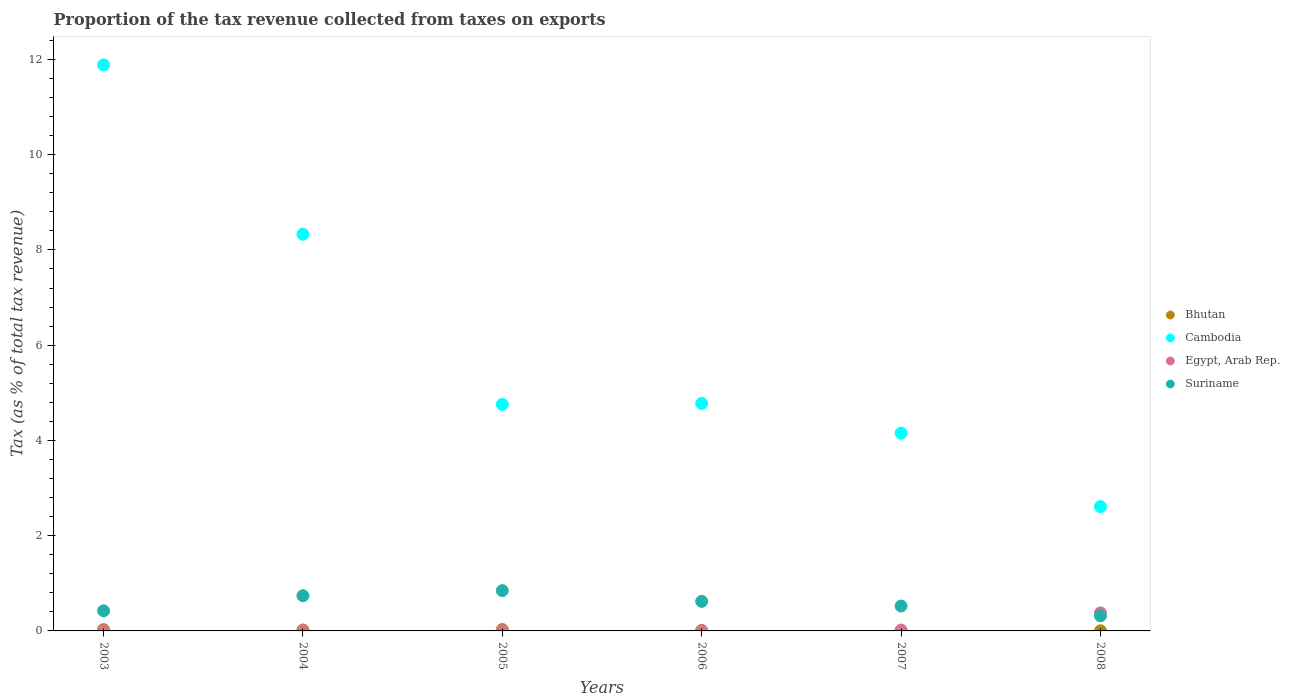What is the proportion of the tax revenue collected in Cambodia in 2004?
Offer a very short reply. 8.33. Across all years, what is the maximum proportion of the tax revenue collected in Bhutan?
Ensure brevity in your answer.  0.03. Across all years, what is the minimum proportion of the tax revenue collected in Bhutan?
Ensure brevity in your answer.  0. What is the total proportion of the tax revenue collected in Suriname in the graph?
Ensure brevity in your answer.  3.47. What is the difference between the proportion of the tax revenue collected in Egypt, Arab Rep. in 2004 and that in 2007?
Make the answer very short. -0.02. What is the difference between the proportion of the tax revenue collected in Bhutan in 2004 and the proportion of the tax revenue collected in Suriname in 2008?
Your response must be concise. -0.3. What is the average proportion of the tax revenue collected in Bhutan per year?
Offer a very short reply. 0.01. In the year 2003, what is the difference between the proportion of the tax revenue collected in Egypt, Arab Rep. and proportion of the tax revenue collected in Suriname?
Your answer should be compact. -0.42. What is the ratio of the proportion of the tax revenue collected in Suriname in 2004 to that in 2007?
Offer a terse response. 1.41. Is the difference between the proportion of the tax revenue collected in Egypt, Arab Rep. in 2004 and 2006 greater than the difference between the proportion of the tax revenue collected in Suriname in 2004 and 2006?
Keep it short and to the point. No. What is the difference between the highest and the second highest proportion of the tax revenue collected in Cambodia?
Offer a terse response. 3.56. What is the difference between the highest and the lowest proportion of the tax revenue collected in Cambodia?
Keep it short and to the point. 9.28. Is it the case that in every year, the sum of the proportion of the tax revenue collected in Egypt, Arab Rep. and proportion of the tax revenue collected in Bhutan  is greater than the sum of proportion of the tax revenue collected in Cambodia and proportion of the tax revenue collected in Suriname?
Offer a very short reply. No. Does the proportion of the tax revenue collected in Suriname monotonically increase over the years?
Your response must be concise. No. Is the proportion of the tax revenue collected in Bhutan strictly less than the proportion of the tax revenue collected in Suriname over the years?
Give a very brief answer. Yes. What is the difference between two consecutive major ticks on the Y-axis?
Offer a terse response. 2. Does the graph contain any zero values?
Provide a short and direct response. No. How are the legend labels stacked?
Provide a succinct answer. Vertical. What is the title of the graph?
Provide a short and direct response. Proportion of the tax revenue collected from taxes on exports. What is the label or title of the X-axis?
Your answer should be very brief. Years. What is the label or title of the Y-axis?
Keep it short and to the point. Tax (as % of total tax revenue). What is the Tax (as % of total tax revenue) of Bhutan in 2003?
Provide a short and direct response. 0.03. What is the Tax (as % of total tax revenue) of Cambodia in 2003?
Offer a terse response. 11.89. What is the Tax (as % of total tax revenue) of Egypt, Arab Rep. in 2003?
Provide a succinct answer. 0. What is the Tax (as % of total tax revenue) of Suriname in 2003?
Ensure brevity in your answer.  0.42. What is the Tax (as % of total tax revenue) of Bhutan in 2004?
Your answer should be very brief. 0.02. What is the Tax (as % of total tax revenue) in Cambodia in 2004?
Your answer should be very brief. 8.33. What is the Tax (as % of total tax revenue) of Egypt, Arab Rep. in 2004?
Your answer should be very brief. 0. What is the Tax (as % of total tax revenue) in Suriname in 2004?
Your answer should be very brief. 0.74. What is the Tax (as % of total tax revenue) of Bhutan in 2005?
Ensure brevity in your answer.  0.03. What is the Tax (as % of total tax revenue) of Cambodia in 2005?
Offer a terse response. 4.76. What is the Tax (as % of total tax revenue) in Egypt, Arab Rep. in 2005?
Give a very brief answer. 0. What is the Tax (as % of total tax revenue) in Suriname in 2005?
Keep it short and to the point. 0.85. What is the Tax (as % of total tax revenue) of Bhutan in 2006?
Your response must be concise. 0.01. What is the Tax (as % of total tax revenue) in Cambodia in 2006?
Your answer should be compact. 4.78. What is the Tax (as % of total tax revenue) in Egypt, Arab Rep. in 2006?
Provide a succinct answer. 0. What is the Tax (as % of total tax revenue) of Suriname in 2006?
Your answer should be very brief. 0.62. What is the Tax (as % of total tax revenue) in Bhutan in 2007?
Your response must be concise. 0. What is the Tax (as % of total tax revenue) of Cambodia in 2007?
Your response must be concise. 4.15. What is the Tax (as % of total tax revenue) in Egypt, Arab Rep. in 2007?
Your response must be concise. 0.02. What is the Tax (as % of total tax revenue) in Suriname in 2007?
Offer a very short reply. 0.52. What is the Tax (as % of total tax revenue) of Bhutan in 2008?
Provide a short and direct response. 0. What is the Tax (as % of total tax revenue) of Cambodia in 2008?
Provide a short and direct response. 2.61. What is the Tax (as % of total tax revenue) in Egypt, Arab Rep. in 2008?
Offer a terse response. 0.38. What is the Tax (as % of total tax revenue) of Suriname in 2008?
Offer a terse response. 0.32. Across all years, what is the maximum Tax (as % of total tax revenue) in Bhutan?
Provide a short and direct response. 0.03. Across all years, what is the maximum Tax (as % of total tax revenue) in Cambodia?
Provide a short and direct response. 11.89. Across all years, what is the maximum Tax (as % of total tax revenue) of Egypt, Arab Rep.?
Provide a short and direct response. 0.38. Across all years, what is the maximum Tax (as % of total tax revenue) in Suriname?
Give a very brief answer. 0.85. Across all years, what is the minimum Tax (as % of total tax revenue) of Bhutan?
Offer a terse response. 0. Across all years, what is the minimum Tax (as % of total tax revenue) of Cambodia?
Your response must be concise. 2.61. Across all years, what is the minimum Tax (as % of total tax revenue) in Egypt, Arab Rep.?
Make the answer very short. 0. Across all years, what is the minimum Tax (as % of total tax revenue) in Suriname?
Offer a very short reply. 0.32. What is the total Tax (as % of total tax revenue) of Bhutan in the graph?
Provide a succinct answer. 0.09. What is the total Tax (as % of total tax revenue) of Cambodia in the graph?
Provide a short and direct response. 36.51. What is the total Tax (as % of total tax revenue) of Egypt, Arab Rep. in the graph?
Offer a terse response. 0.4. What is the total Tax (as % of total tax revenue) of Suriname in the graph?
Make the answer very short. 3.47. What is the difference between the Tax (as % of total tax revenue) of Bhutan in 2003 and that in 2004?
Your response must be concise. 0.01. What is the difference between the Tax (as % of total tax revenue) in Cambodia in 2003 and that in 2004?
Offer a terse response. 3.56. What is the difference between the Tax (as % of total tax revenue) in Egypt, Arab Rep. in 2003 and that in 2004?
Provide a succinct answer. -0. What is the difference between the Tax (as % of total tax revenue) of Suriname in 2003 and that in 2004?
Your response must be concise. -0.32. What is the difference between the Tax (as % of total tax revenue) of Bhutan in 2003 and that in 2005?
Give a very brief answer. -0. What is the difference between the Tax (as % of total tax revenue) in Cambodia in 2003 and that in 2005?
Your answer should be compact. 7.13. What is the difference between the Tax (as % of total tax revenue) of Egypt, Arab Rep. in 2003 and that in 2005?
Offer a terse response. 0. What is the difference between the Tax (as % of total tax revenue) of Suriname in 2003 and that in 2005?
Provide a succinct answer. -0.42. What is the difference between the Tax (as % of total tax revenue) in Bhutan in 2003 and that in 2006?
Keep it short and to the point. 0.02. What is the difference between the Tax (as % of total tax revenue) in Cambodia in 2003 and that in 2006?
Your answer should be very brief. 7.11. What is the difference between the Tax (as % of total tax revenue) of Suriname in 2003 and that in 2006?
Give a very brief answer. -0.2. What is the difference between the Tax (as % of total tax revenue) in Bhutan in 2003 and that in 2007?
Offer a terse response. 0.03. What is the difference between the Tax (as % of total tax revenue) in Cambodia in 2003 and that in 2007?
Offer a terse response. 7.73. What is the difference between the Tax (as % of total tax revenue) in Egypt, Arab Rep. in 2003 and that in 2007?
Provide a short and direct response. -0.02. What is the difference between the Tax (as % of total tax revenue) of Suriname in 2003 and that in 2007?
Provide a succinct answer. -0.1. What is the difference between the Tax (as % of total tax revenue) of Bhutan in 2003 and that in 2008?
Keep it short and to the point. 0.03. What is the difference between the Tax (as % of total tax revenue) of Cambodia in 2003 and that in 2008?
Provide a short and direct response. 9.28. What is the difference between the Tax (as % of total tax revenue) of Egypt, Arab Rep. in 2003 and that in 2008?
Your answer should be very brief. -0.38. What is the difference between the Tax (as % of total tax revenue) of Suriname in 2003 and that in 2008?
Ensure brevity in your answer.  0.1. What is the difference between the Tax (as % of total tax revenue) of Bhutan in 2004 and that in 2005?
Ensure brevity in your answer.  -0.01. What is the difference between the Tax (as % of total tax revenue) of Cambodia in 2004 and that in 2005?
Provide a short and direct response. 3.57. What is the difference between the Tax (as % of total tax revenue) of Egypt, Arab Rep. in 2004 and that in 2005?
Offer a very short reply. 0. What is the difference between the Tax (as % of total tax revenue) of Suriname in 2004 and that in 2005?
Your response must be concise. -0.11. What is the difference between the Tax (as % of total tax revenue) of Bhutan in 2004 and that in 2006?
Offer a very short reply. 0.01. What is the difference between the Tax (as % of total tax revenue) in Cambodia in 2004 and that in 2006?
Your response must be concise. 3.55. What is the difference between the Tax (as % of total tax revenue) in Egypt, Arab Rep. in 2004 and that in 2006?
Ensure brevity in your answer.  0. What is the difference between the Tax (as % of total tax revenue) of Suriname in 2004 and that in 2006?
Provide a succinct answer. 0.12. What is the difference between the Tax (as % of total tax revenue) of Bhutan in 2004 and that in 2007?
Keep it short and to the point. 0.02. What is the difference between the Tax (as % of total tax revenue) in Cambodia in 2004 and that in 2007?
Your answer should be very brief. 4.18. What is the difference between the Tax (as % of total tax revenue) of Egypt, Arab Rep. in 2004 and that in 2007?
Your answer should be compact. -0.02. What is the difference between the Tax (as % of total tax revenue) of Suriname in 2004 and that in 2007?
Ensure brevity in your answer.  0.22. What is the difference between the Tax (as % of total tax revenue) in Bhutan in 2004 and that in 2008?
Give a very brief answer. 0.02. What is the difference between the Tax (as % of total tax revenue) in Cambodia in 2004 and that in 2008?
Give a very brief answer. 5.72. What is the difference between the Tax (as % of total tax revenue) of Egypt, Arab Rep. in 2004 and that in 2008?
Your response must be concise. -0.38. What is the difference between the Tax (as % of total tax revenue) in Suriname in 2004 and that in 2008?
Your answer should be compact. 0.42. What is the difference between the Tax (as % of total tax revenue) in Bhutan in 2005 and that in 2006?
Make the answer very short. 0.02. What is the difference between the Tax (as % of total tax revenue) of Cambodia in 2005 and that in 2006?
Offer a very short reply. -0.02. What is the difference between the Tax (as % of total tax revenue) in Egypt, Arab Rep. in 2005 and that in 2006?
Offer a terse response. -0. What is the difference between the Tax (as % of total tax revenue) of Suriname in 2005 and that in 2006?
Offer a very short reply. 0.23. What is the difference between the Tax (as % of total tax revenue) of Bhutan in 2005 and that in 2007?
Provide a succinct answer. 0.03. What is the difference between the Tax (as % of total tax revenue) in Cambodia in 2005 and that in 2007?
Ensure brevity in your answer.  0.6. What is the difference between the Tax (as % of total tax revenue) of Egypt, Arab Rep. in 2005 and that in 2007?
Provide a succinct answer. -0.02. What is the difference between the Tax (as % of total tax revenue) of Suriname in 2005 and that in 2007?
Provide a short and direct response. 0.32. What is the difference between the Tax (as % of total tax revenue) in Bhutan in 2005 and that in 2008?
Make the answer very short. 0.03. What is the difference between the Tax (as % of total tax revenue) of Cambodia in 2005 and that in 2008?
Ensure brevity in your answer.  2.15. What is the difference between the Tax (as % of total tax revenue) of Egypt, Arab Rep. in 2005 and that in 2008?
Give a very brief answer. -0.38. What is the difference between the Tax (as % of total tax revenue) of Suriname in 2005 and that in 2008?
Your answer should be compact. 0.53. What is the difference between the Tax (as % of total tax revenue) in Bhutan in 2006 and that in 2007?
Make the answer very short. 0.01. What is the difference between the Tax (as % of total tax revenue) of Cambodia in 2006 and that in 2007?
Your answer should be compact. 0.62. What is the difference between the Tax (as % of total tax revenue) in Egypt, Arab Rep. in 2006 and that in 2007?
Offer a very short reply. -0.02. What is the difference between the Tax (as % of total tax revenue) in Suriname in 2006 and that in 2007?
Offer a terse response. 0.1. What is the difference between the Tax (as % of total tax revenue) of Bhutan in 2006 and that in 2008?
Your response must be concise. 0.01. What is the difference between the Tax (as % of total tax revenue) of Cambodia in 2006 and that in 2008?
Keep it short and to the point. 2.17. What is the difference between the Tax (as % of total tax revenue) of Egypt, Arab Rep. in 2006 and that in 2008?
Keep it short and to the point. -0.38. What is the difference between the Tax (as % of total tax revenue) in Suriname in 2006 and that in 2008?
Give a very brief answer. 0.3. What is the difference between the Tax (as % of total tax revenue) of Bhutan in 2007 and that in 2008?
Make the answer very short. -0. What is the difference between the Tax (as % of total tax revenue) in Cambodia in 2007 and that in 2008?
Offer a very short reply. 1.54. What is the difference between the Tax (as % of total tax revenue) of Egypt, Arab Rep. in 2007 and that in 2008?
Provide a succinct answer. -0.36. What is the difference between the Tax (as % of total tax revenue) in Suriname in 2007 and that in 2008?
Offer a very short reply. 0.2. What is the difference between the Tax (as % of total tax revenue) of Bhutan in 2003 and the Tax (as % of total tax revenue) of Cambodia in 2004?
Ensure brevity in your answer.  -8.3. What is the difference between the Tax (as % of total tax revenue) of Bhutan in 2003 and the Tax (as % of total tax revenue) of Egypt, Arab Rep. in 2004?
Offer a very short reply. 0.03. What is the difference between the Tax (as % of total tax revenue) of Bhutan in 2003 and the Tax (as % of total tax revenue) of Suriname in 2004?
Provide a succinct answer. -0.71. What is the difference between the Tax (as % of total tax revenue) in Cambodia in 2003 and the Tax (as % of total tax revenue) in Egypt, Arab Rep. in 2004?
Provide a succinct answer. 11.88. What is the difference between the Tax (as % of total tax revenue) in Cambodia in 2003 and the Tax (as % of total tax revenue) in Suriname in 2004?
Your answer should be compact. 11.15. What is the difference between the Tax (as % of total tax revenue) of Egypt, Arab Rep. in 2003 and the Tax (as % of total tax revenue) of Suriname in 2004?
Provide a succinct answer. -0.74. What is the difference between the Tax (as % of total tax revenue) of Bhutan in 2003 and the Tax (as % of total tax revenue) of Cambodia in 2005?
Provide a succinct answer. -4.73. What is the difference between the Tax (as % of total tax revenue) of Bhutan in 2003 and the Tax (as % of total tax revenue) of Egypt, Arab Rep. in 2005?
Your response must be concise. 0.03. What is the difference between the Tax (as % of total tax revenue) in Bhutan in 2003 and the Tax (as % of total tax revenue) in Suriname in 2005?
Your answer should be compact. -0.82. What is the difference between the Tax (as % of total tax revenue) of Cambodia in 2003 and the Tax (as % of total tax revenue) of Egypt, Arab Rep. in 2005?
Give a very brief answer. 11.88. What is the difference between the Tax (as % of total tax revenue) of Cambodia in 2003 and the Tax (as % of total tax revenue) of Suriname in 2005?
Ensure brevity in your answer.  11.04. What is the difference between the Tax (as % of total tax revenue) in Egypt, Arab Rep. in 2003 and the Tax (as % of total tax revenue) in Suriname in 2005?
Your response must be concise. -0.84. What is the difference between the Tax (as % of total tax revenue) of Bhutan in 2003 and the Tax (as % of total tax revenue) of Cambodia in 2006?
Offer a very short reply. -4.75. What is the difference between the Tax (as % of total tax revenue) of Bhutan in 2003 and the Tax (as % of total tax revenue) of Egypt, Arab Rep. in 2006?
Offer a terse response. 0.03. What is the difference between the Tax (as % of total tax revenue) in Bhutan in 2003 and the Tax (as % of total tax revenue) in Suriname in 2006?
Your answer should be compact. -0.59. What is the difference between the Tax (as % of total tax revenue) of Cambodia in 2003 and the Tax (as % of total tax revenue) of Egypt, Arab Rep. in 2006?
Make the answer very short. 11.88. What is the difference between the Tax (as % of total tax revenue) in Cambodia in 2003 and the Tax (as % of total tax revenue) in Suriname in 2006?
Provide a succinct answer. 11.27. What is the difference between the Tax (as % of total tax revenue) of Egypt, Arab Rep. in 2003 and the Tax (as % of total tax revenue) of Suriname in 2006?
Offer a terse response. -0.62. What is the difference between the Tax (as % of total tax revenue) of Bhutan in 2003 and the Tax (as % of total tax revenue) of Cambodia in 2007?
Keep it short and to the point. -4.12. What is the difference between the Tax (as % of total tax revenue) in Bhutan in 2003 and the Tax (as % of total tax revenue) in Egypt, Arab Rep. in 2007?
Provide a short and direct response. 0.01. What is the difference between the Tax (as % of total tax revenue) in Bhutan in 2003 and the Tax (as % of total tax revenue) in Suriname in 2007?
Give a very brief answer. -0.49. What is the difference between the Tax (as % of total tax revenue) of Cambodia in 2003 and the Tax (as % of total tax revenue) of Egypt, Arab Rep. in 2007?
Make the answer very short. 11.87. What is the difference between the Tax (as % of total tax revenue) of Cambodia in 2003 and the Tax (as % of total tax revenue) of Suriname in 2007?
Your answer should be very brief. 11.36. What is the difference between the Tax (as % of total tax revenue) in Egypt, Arab Rep. in 2003 and the Tax (as % of total tax revenue) in Suriname in 2007?
Give a very brief answer. -0.52. What is the difference between the Tax (as % of total tax revenue) of Bhutan in 2003 and the Tax (as % of total tax revenue) of Cambodia in 2008?
Your response must be concise. -2.58. What is the difference between the Tax (as % of total tax revenue) of Bhutan in 2003 and the Tax (as % of total tax revenue) of Egypt, Arab Rep. in 2008?
Your answer should be very brief. -0.35. What is the difference between the Tax (as % of total tax revenue) in Bhutan in 2003 and the Tax (as % of total tax revenue) in Suriname in 2008?
Give a very brief answer. -0.29. What is the difference between the Tax (as % of total tax revenue) in Cambodia in 2003 and the Tax (as % of total tax revenue) in Egypt, Arab Rep. in 2008?
Keep it short and to the point. 11.51. What is the difference between the Tax (as % of total tax revenue) of Cambodia in 2003 and the Tax (as % of total tax revenue) of Suriname in 2008?
Offer a very short reply. 11.57. What is the difference between the Tax (as % of total tax revenue) of Egypt, Arab Rep. in 2003 and the Tax (as % of total tax revenue) of Suriname in 2008?
Keep it short and to the point. -0.32. What is the difference between the Tax (as % of total tax revenue) of Bhutan in 2004 and the Tax (as % of total tax revenue) of Cambodia in 2005?
Your answer should be very brief. -4.74. What is the difference between the Tax (as % of total tax revenue) in Bhutan in 2004 and the Tax (as % of total tax revenue) in Egypt, Arab Rep. in 2005?
Provide a succinct answer. 0.02. What is the difference between the Tax (as % of total tax revenue) of Bhutan in 2004 and the Tax (as % of total tax revenue) of Suriname in 2005?
Give a very brief answer. -0.83. What is the difference between the Tax (as % of total tax revenue) in Cambodia in 2004 and the Tax (as % of total tax revenue) in Egypt, Arab Rep. in 2005?
Keep it short and to the point. 8.33. What is the difference between the Tax (as % of total tax revenue) of Cambodia in 2004 and the Tax (as % of total tax revenue) of Suriname in 2005?
Provide a succinct answer. 7.48. What is the difference between the Tax (as % of total tax revenue) in Egypt, Arab Rep. in 2004 and the Tax (as % of total tax revenue) in Suriname in 2005?
Give a very brief answer. -0.84. What is the difference between the Tax (as % of total tax revenue) of Bhutan in 2004 and the Tax (as % of total tax revenue) of Cambodia in 2006?
Make the answer very short. -4.76. What is the difference between the Tax (as % of total tax revenue) in Bhutan in 2004 and the Tax (as % of total tax revenue) in Egypt, Arab Rep. in 2006?
Your answer should be very brief. 0.02. What is the difference between the Tax (as % of total tax revenue) in Bhutan in 2004 and the Tax (as % of total tax revenue) in Suriname in 2006?
Keep it short and to the point. -0.6. What is the difference between the Tax (as % of total tax revenue) of Cambodia in 2004 and the Tax (as % of total tax revenue) of Egypt, Arab Rep. in 2006?
Ensure brevity in your answer.  8.33. What is the difference between the Tax (as % of total tax revenue) in Cambodia in 2004 and the Tax (as % of total tax revenue) in Suriname in 2006?
Your response must be concise. 7.71. What is the difference between the Tax (as % of total tax revenue) of Egypt, Arab Rep. in 2004 and the Tax (as % of total tax revenue) of Suriname in 2006?
Your answer should be very brief. -0.62. What is the difference between the Tax (as % of total tax revenue) in Bhutan in 2004 and the Tax (as % of total tax revenue) in Cambodia in 2007?
Offer a very short reply. -4.13. What is the difference between the Tax (as % of total tax revenue) in Bhutan in 2004 and the Tax (as % of total tax revenue) in Egypt, Arab Rep. in 2007?
Make the answer very short. 0. What is the difference between the Tax (as % of total tax revenue) of Bhutan in 2004 and the Tax (as % of total tax revenue) of Suriname in 2007?
Your answer should be compact. -0.5. What is the difference between the Tax (as % of total tax revenue) of Cambodia in 2004 and the Tax (as % of total tax revenue) of Egypt, Arab Rep. in 2007?
Provide a short and direct response. 8.31. What is the difference between the Tax (as % of total tax revenue) of Cambodia in 2004 and the Tax (as % of total tax revenue) of Suriname in 2007?
Provide a succinct answer. 7.81. What is the difference between the Tax (as % of total tax revenue) in Egypt, Arab Rep. in 2004 and the Tax (as % of total tax revenue) in Suriname in 2007?
Keep it short and to the point. -0.52. What is the difference between the Tax (as % of total tax revenue) in Bhutan in 2004 and the Tax (as % of total tax revenue) in Cambodia in 2008?
Your answer should be compact. -2.59. What is the difference between the Tax (as % of total tax revenue) in Bhutan in 2004 and the Tax (as % of total tax revenue) in Egypt, Arab Rep. in 2008?
Offer a terse response. -0.36. What is the difference between the Tax (as % of total tax revenue) in Bhutan in 2004 and the Tax (as % of total tax revenue) in Suriname in 2008?
Your answer should be very brief. -0.3. What is the difference between the Tax (as % of total tax revenue) of Cambodia in 2004 and the Tax (as % of total tax revenue) of Egypt, Arab Rep. in 2008?
Ensure brevity in your answer.  7.95. What is the difference between the Tax (as % of total tax revenue) of Cambodia in 2004 and the Tax (as % of total tax revenue) of Suriname in 2008?
Offer a very short reply. 8.01. What is the difference between the Tax (as % of total tax revenue) in Egypt, Arab Rep. in 2004 and the Tax (as % of total tax revenue) in Suriname in 2008?
Your response must be concise. -0.32. What is the difference between the Tax (as % of total tax revenue) of Bhutan in 2005 and the Tax (as % of total tax revenue) of Cambodia in 2006?
Provide a short and direct response. -4.75. What is the difference between the Tax (as % of total tax revenue) of Bhutan in 2005 and the Tax (as % of total tax revenue) of Egypt, Arab Rep. in 2006?
Offer a very short reply. 0.03. What is the difference between the Tax (as % of total tax revenue) in Bhutan in 2005 and the Tax (as % of total tax revenue) in Suriname in 2006?
Your answer should be compact. -0.59. What is the difference between the Tax (as % of total tax revenue) in Cambodia in 2005 and the Tax (as % of total tax revenue) in Egypt, Arab Rep. in 2006?
Make the answer very short. 4.75. What is the difference between the Tax (as % of total tax revenue) of Cambodia in 2005 and the Tax (as % of total tax revenue) of Suriname in 2006?
Ensure brevity in your answer.  4.14. What is the difference between the Tax (as % of total tax revenue) in Egypt, Arab Rep. in 2005 and the Tax (as % of total tax revenue) in Suriname in 2006?
Ensure brevity in your answer.  -0.62. What is the difference between the Tax (as % of total tax revenue) of Bhutan in 2005 and the Tax (as % of total tax revenue) of Cambodia in 2007?
Keep it short and to the point. -4.12. What is the difference between the Tax (as % of total tax revenue) in Bhutan in 2005 and the Tax (as % of total tax revenue) in Suriname in 2007?
Your response must be concise. -0.49. What is the difference between the Tax (as % of total tax revenue) in Cambodia in 2005 and the Tax (as % of total tax revenue) in Egypt, Arab Rep. in 2007?
Offer a very short reply. 4.74. What is the difference between the Tax (as % of total tax revenue) in Cambodia in 2005 and the Tax (as % of total tax revenue) in Suriname in 2007?
Keep it short and to the point. 4.23. What is the difference between the Tax (as % of total tax revenue) of Egypt, Arab Rep. in 2005 and the Tax (as % of total tax revenue) of Suriname in 2007?
Offer a very short reply. -0.52. What is the difference between the Tax (as % of total tax revenue) in Bhutan in 2005 and the Tax (as % of total tax revenue) in Cambodia in 2008?
Keep it short and to the point. -2.58. What is the difference between the Tax (as % of total tax revenue) in Bhutan in 2005 and the Tax (as % of total tax revenue) in Egypt, Arab Rep. in 2008?
Provide a succinct answer. -0.35. What is the difference between the Tax (as % of total tax revenue) in Bhutan in 2005 and the Tax (as % of total tax revenue) in Suriname in 2008?
Provide a succinct answer. -0.29. What is the difference between the Tax (as % of total tax revenue) in Cambodia in 2005 and the Tax (as % of total tax revenue) in Egypt, Arab Rep. in 2008?
Offer a terse response. 4.38. What is the difference between the Tax (as % of total tax revenue) in Cambodia in 2005 and the Tax (as % of total tax revenue) in Suriname in 2008?
Ensure brevity in your answer.  4.44. What is the difference between the Tax (as % of total tax revenue) of Egypt, Arab Rep. in 2005 and the Tax (as % of total tax revenue) of Suriname in 2008?
Your answer should be very brief. -0.32. What is the difference between the Tax (as % of total tax revenue) of Bhutan in 2006 and the Tax (as % of total tax revenue) of Cambodia in 2007?
Offer a terse response. -4.14. What is the difference between the Tax (as % of total tax revenue) of Bhutan in 2006 and the Tax (as % of total tax revenue) of Egypt, Arab Rep. in 2007?
Give a very brief answer. -0.01. What is the difference between the Tax (as % of total tax revenue) of Bhutan in 2006 and the Tax (as % of total tax revenue) of Suriname in 2007?
Ensure brevity in your answer.  -0.51. What is the difference between the Tax (as % of total tax revenue) in Cambodia in 2006 and the Tax (as % of total tax revenue) in Egypt, Arab Rep. in 2007?
Your answer should be compact. 4.76. What is the difference between the Tax (as % of total tax revenue) of Cambodia in 2006 and the Tax (as % of total tax revenue) of Suriname in 2007?
Ensure brevity in your answer.  4.25. What is the difference between the Tax (as % of total tax revenue) in Egypt, Arab Rep. in 2006 and the Tax (as % of total tax revenue) in Suriname in 2007?
Make the answer very short. -0.52. What is the difference between the Tax (as % of total tax revenue) in Bhutan in 2006 and the Tax (as % of total tax revenue) in Cambodia in 2008?
Your answer should be very brief. -2.6. What is the difference between the Tax (as % of total tax revenue) in Bhutan in 2006 and the Tax (as % of total tax revenue) in Egypt, Arab Rep. in 2008?
Offer a very short reply. -0.37. What is the difference between the Tax (as % of total tax revenue) in Bhutan in 2006 and the Tax (as % of total tax revenue) in Suriname in 2008?
Offer a very short reply. -0.31. What is the difference between the Tax (as % of total tax revenue) in Cambodia in 2006 and the Tax (as % of total tax revenue) in Egypt, Arab Rep. in 2008?
Your answer should be very brief. 4.4. What is the difference between the Tax (as % of total tax revenue) in Cambodia in 2006 and the Tax (as % of total tax revenue) in Suriname in 2008?
Make the answer very short. 4.46. What is the difference between the Tax (as % of total tax revenue) in Egypt, Arab Rep. in 2006 and the Tax (as % of total tax revenue) in Suriname in 2008?
Your response must be concise. -0.32. What is the difference between the Tax (as % of total tax revenue) in Bhutan in 2007 and the Tax (as % of total tax revenue) in Cambodia in 2008?
Provide a short and direct response. -2.61. What is the difference between the Tax (as % of total tax revenue) of Bhutan in 2007 and the Tax (as % of total tax revenue) of Egypt, Arab Rep. in 2008?
Provide a succinct answer. -0.38. What is the difference between the Tax (as % of total tax revenue) of Bhutan in 2007 and the Tax (as % of total tax revenue) of Suriname in 2008?
Make the answer very short. -0.32. What is the difference between the Tax (as % of total tax revenue) in Cambodia in 2007 and the Tax (as % of total tax revenue) in Egypt, Arab Rep. in 2008?
Provide a short and direct response. 3.77. What is the difference between the Tax (as % of total tax revenue) of Cambodia in 2007 and the Tax (as % of total tax revenue) of Suriname in 2008?
Offer a very short reply. 3.83. What is the difference between the Tax (as % of total tax revenue) in Egypt, Arab Rep. in 2007 and the Tax (as % of total tax revenue) in Suriname in 2008?
Ensure brevity in your answer.  -0.3. What is the average Tax (as % of total tax revenue) in Bhutan per year?
Make the answer very short. 0.01. What is the average Tax (as % of total tax revenue) in Cambodia per year?
Keep it short and to the point. 6.09. What is the average Tax (as % of total tax revenue) in Egypt, Arab Rep. per year?
Offer a terse response. 0.07. What is the average Tax (as % of total tax revenue) of Suriname per year?
Offer a terse response. 0.58. In the year 2003, what is the difference between the Tax (as % of total tax revenue) in Bhutan and Tax (as % of total tax revenue) in Cambodia?
Provide a succinct answer. -11.86. In the year 2003, what is the difference between the Tax (as % of total tax revenue) of Bhutan and Tax (as % of total tax revenue) of Egypt, Arab Rep.?
Keep it short and to the point. 0.03. In the year 2003, what is the difference between the Tax (as % of total tax revenue) in Bhutan and Tax (as % of total tax revenue) in Suriname?
Your response must be concise. -0.39. In the year 2003, what is the difference between the Tax (as % of total tax revenue) in Cambodia and Tax (as % of total tax revenue) in Egypt, Arab Rep.?
Your answer should be very brief. 11.88. In the year 2003, what is the difference between the Tax (as % of total tax revenue) in Cambodia and Tax (as % of total tax revenue) in Suriname?
Your response must be concise. 11.46. In the year 2003, what is the difference between the Tax (as % of total tax revenue) of Egypt, Arab Rep. and Tax (as % of total tax revenue) of Suriname?
Your answer should be compact. -0.42. In the year 2004, what is the difference between the Tax (as % of total tax revenue) of Bhutan and Tax (as % of total tax revenue) of Cambodia?
Provide a short and direct response. -8.31. In the year 2004, what is the difference between the Tax (as % of total tax revenue) of Bhutan and Tax (as % of total tax revenue) of Egypt, Arab Rep.?
Provide a succinct answer. 0.02. In the year 2004, what is the difference between the Tax (as % of total tax revenue) of Bhutan and Tax (as % of total tax revenue) of Suriname?
Make the answer very short. -0.72. In the year 2004, what is the difference between the Tax (as % of total tax revenue) of Cambodia and Tax (as % of total tax revenue) of Egypt, Arab Rep.?
Offer a very short reply. 8.33. In the year 2004, what is the difference between the Tax (as % of total tax revenue) in Cambodia and Tax (as % of total tax revenue) in Suriname?
Ensure brevity in your answer.  7.59. In the year 2004, what is the difference between the Tax (as % of total tax revenue) in Egypt, Arab Rep. and Tax (as % of total tax revenue) in Suriname?
Keep it short and to the point. -0.74. In the year 2005, what is the difference between the Tax (as % of total tax revenue) in Bhutan and Tax (as % of total tax revenue) in Cambodia?
Keep it short and to the point. -4.73. In the year 2005, what is the difference between the Tax (as % of total tax revenue) of Bhutan and Tax (as % of total tax revenue) of Egypt, Arab Rep.?
Give a very brief answer. 0.03. In the year 2005, what is the difference between the Tax (as % of total tax revenue) of Bhutan and Tax (as % of total tax revenue) of Suriname?
Your answer should be very brief. -0.82. In the year 2005, what is the difference between the Tax (as % of total tax revenue) in Cambodia and Tax (as % of total tax revenue) in Egypt, Arab Rep.?
Provide a succinct answer. 4.76. In the year 2005, what is the difference between the Tax (as % of total tax revenue) of Cambodia and Tax (as % of total tax revenue) of Suriname?
Your answer should be compact. 3.91. In the year 2005, what is the difference between the Tax (as % of total tax revenue) of Egypt, Arab Rep. and Tax (as % of total tax revenue) of Suriname?
Ensure brevity in your answer.  -0.84. In the year 2006, what is the difference between the Tax (as % of total tax revenue) of Bhutan and Tax (as % of total tax revenue) of Cambodia?
Your answer should be very brief. -4.77. In the year 2006, what is the difference between the Tax (as % of total tax revenue) of Bhutan and Tax (as % of total tax revenue) of Egypt, Arab Rep.?
Ensure brevity in your answer.  0.01. In the year 2006, what is the difference between the Tax (as % of total tax revenue) of Bhutan and Tax (as % of total tax revenue) of Suriname?
Make the answer very short. -0.61. In the year 2006, what is the difference between the Tax (as % of total tax revenue) in Cambodia and Tax (as % of total tax revenue) in Egypt, Arab Rep.?
Keep it short and to the point. 4.78. In the year 2006, what is the difference between the Tax (as % of total tax revenue) in Cambodia and Tax (as % of total tax revenue) in Suriname?
Your response must be concise. 4.16. In the year 2006, what is the difference between the Tax (as % of total tax revenue) of Egypt, Arab Rep. and Tax (as % of total tax revenue) of Suriname?
Provide a short and direct response. -0.62. In the year 2007, what is the difference between the Tax (as % of total tax revenue) of Bhutan and Tax (as % of total tax revenue) of Cambodia?
Provide a short and direct response. -4.15. In the year 2007, what is the difference between the Tax (as % of total tax revenue) in Bhutan and Tax (as % of total tax revenue) in Egypt, Arab Rep.?
Give a very brief answer. -0.02. In the year 2007, what is the difference between the Tax (as % of total tax revenue) in Bhutan and Tax (as % of total tax revenue) in Suriname?
Make the answer very short. -0.52. In the year 2007, what is the difference between the Tax (as % of total tax revenue) of Cambodia and Tax (as % of total tax revenue) of Egypt, Arab Rep.?
Give a very brief answer. 4.13. In the year 2007, what is the difference between the Tax (as % of total tax revenue) of Cambodia and Tax (as % of total tax revenue) of Suriname?
Ensure brevity in your answer.  3.63. In the year 2007, what is the difference between the Tax (as % of total tax revenue) in Egypt, Arab Rep. and Tax (as % of total tax revenue) in Suriname?
Provide a succinct answer. -0.5. In the year 2008, what is the difference between the Tax (as % of total tax revenue) in Bhutan and Tax (as % of total tax revenue) in Cambodia?
Provide a short and direct response. -2.61. In the year 2008, what is the difference between the Tax (as % of total tax revenue) of Bhutan and Tax (as % of total tax revenue) of Egypt, Arab Rep.?
Make the answer very short. -0.38. In the year 2008, what is the difference between the Tax (as % of total tax revenue) in Bhutan and Tax (as % of total tax revenue) in Suriname?
Your response must be concise. -0.32. In the year 2008, what is the difference between the Tax (as % of total tax revenue) in Cambodia and Tax (as % of total tax revenue) in Egypt, Arab Rep.?
Your answer should be very brief. 2.23. In the year 2008, what is the difference between the Tax (as % of total tax revenue) in Cambodia and Tax (as % of total tax revenue) in Suriname?
Make the answer very short. 2.29. What is the ratio of the Tax (as % of total tax revenue) of Bhutan in 2003 to that in 2004?
Your answer should be compact. 1.4. What is the ratio of the Tax (as % of total tax revenue) in Cambodia in 2003 to that in 2004?
Provide a short and direct response. 1.43. What is the ratio of the Tax (as % of total tax revenue) of Egypt, Arab Rep. in 2003 to that in 2004?
Keep it short and to the point. 0.6. What is the ratio of the Tax (as % of total tax revenue) in Suriname in 2003 to that in 2004?
Keep it short and to the point. 0.57. What is the ratio of the Tax (as % of total tax revenue) of Bhutan in 2003 to that in 2005?
Your response must be concise. 0.97. What is the ratio of the Tax (as % of total tax revenue) in Cambodia in 2003 to that in 2005?
Offer a very short reply. 2.5. What is the ratio of the Tax (as % of total tax revenue) in Egypt, Arab Rep. in 2003 to that in 2005?
Offer a terse response. 1.36. What is the ratio of the Tax (as % of total tax revenue) in Suriname in 2003 to that in 2005?
Your answer should be compact. 0.5. What is the ratio of the Tax (as % of total tax revenue) of Bhutan in 2003 to that in 2006?
Make the answer very short. 3.05. What is the ratio of the Tax (as % of total tax revenue) of Cambodia in 2003 to that in 2006?
Offer a very short reply. 2.49. What is the ratio of the Tax (as % of total tax revenue) of Egypt, Arab Rep. in 2003 to that in 2006?
Provide a short and direct response. 1.17. What is the ratio of the Tax (as % of total tax revenue) of Suriname in 2003 to that in 2006?
Your answer should be very brief. 0.68. What is the ratio of the Tax (as % of total tax revenue) in Bhutan in 2003 to that in 2007?
Provide a short and direct response. 87.14. What is the ratio of the Tax (as % of total tax revenue) in Cambodia in 2003 to that in 2007?
Ensure brevity in your answer.  2.86. What is the ratio of the Tax (as % of total tax revenue) of Egypt, Arab Rep. in 2003 to that in 2007?
Make the answer very short. 0.1. What is the ratio of the Tax (as % of total tax revenue) of Suriname in 2003 to that in 2007?
Your answer should be very brief. 0.81. What is the ratio of the Tax (as % of total tax revenue) of Bhutan in 2003 to that in 2008?
Your response must be concise. 12.46. What is the ratio of the Tax (as % of total tax revenue) of Cambodia in 2003 to that in 2008?
Provide a short and direct response. 4.55. What is the ratio of the Tax (as % of total tax revenue) of Egypt, Arab Rep. in 2003 to that in 2008?
Keep it short and to the point. 0. What is the ratio of the Tax (as % of total tax revenue) in Suriname in 2003 to that in 2008?
Your response must be concise. 1.33. What is the ratio of the Tax (as % of total tax revenue) in Bhutan in 2004 to that in 2005?
Keep it short and to the point. 0.7. What is the ratio of the Tax (as % of total tax revenue) of Cambodia in 2004 to that in 2005?
Your answer should be very brief. 1.75. What is the ratio of the Tax (as % of total tax revenue) of Egypt, Arab Rep. in 2004 to that in 2005?
Your answer should be compact. 2.26. What is the ratio of the Tax (as % of total tax revenue) in Suriname in 2004 to that in 2005?
Your answer should be compact. 0.87. What is the ratio of the Tax (as % of total tax revenue) in Bhutan in 2004 to that in 2006?
Provide a short and direct response. 2.17. What is the ratio of the Tax (as % of total tax revenue) in Cambodia in 2004 to that in 2006?
Provide a succinct answer. 1.74. What is the ratio of the Tax (as % of total tax revenue) of Egypt, Arab Rep. in 2004 to that in 2006?
Provide a succinct answer. 1.94. What is the ratio of the Tax (as % of total tax revenue) of Suriname in 2004 to that in 2006?
Offer a very short reply. 1.19. What is the ratio of the Tax (as % of total tax revenue) of Bhutan in 2004 to that in 2007?
Offer a terse response. 62.19. What is the ratio of the Tax (as % of total tax revenue) in Cambodia in 2004 to that in 2007?
Provide a short and direct response. 2.01. What is the ratio of the Tax (as % of total tax revenue) in Egypt, Arab Rep. in 2004 to that in 2007?
Keep it short and to the point. 0.16. What is the ratio of the Tax (as % of total tax revenue) in Suriname in 2004 to that in 2007?
Your answer should be compact. 1.41. What is the ratio of the Tax (as % of total tax revenue) in Bhutan in 2004 to that in 2008?
Keep it short and to the point. 8.89. What is the ratio of the Tax (as % of total tax revenue) of Cambodia in 2004 to that in 2008?
Offer a terse response. 3.19. What is the ratio of the Tax (as % of total tax revenue) of Egypt, Arab Rep. in 2004 to that in 2008?
Offer a very short reply. 0.01. What is the ratio of the Tax (as % of total tax revenue) of Suriname in 2004 to that in 2008?
Offer a terse response. 2.32. What is the ratio of the Tax (as % of total tax revenue) of Bhutan in 2005 to that in 2006?
Provide a succinct answer. 3.13. What is the ratio of the Tax (as % of total tax revenue) in Egypt, Arab Rep. in 2005 to that in 2006?
Make the answer very short. 0.86. What is the ratio of the Tax (as % of total tax revenue) of Suriname in 2005 to that in 2006?
Ensure brevity in your answer.  1.36. What is the ratio of the Tax (as % of total tax revenue) in Bhutan in 2005 to that in 2007?
Offer a very short reply. 89.45. What is the ratio of the Tax (as % of total tax revenue) of Cambodia in 2005 to that in 2007?
Ensure brevity in your answer.  1.15. What is the ratio of the Tax (as % of total tax revenue) of Egypt, Arab Rep. in 2005 to that in 2007?
Your response must be concise. 0.07. What is the ratio of the Tax (as % of total tax revenue) in Suriname in 2005 to that in 2007?
Your answer should be compact. 1.62. What is the ratio of the Tax (as % of total tax revenue) in Bhutan in 2005 to that in 2008?
Provide a succinct answer. 12.79. What is the ratio of the Tax (as % of total tax revenue) in Cambodia in 2005 to that in 2008?
Provide a succinct answer. 1.82. What is the ratio of the Tax (as % of total tax revenue) of Egypt, Arab Rep. in 2005 to that in 2008?
Your answer should be compact. 0. What is the ratio of the Tax (as % of total tax revenue) in Suriname in 2005 to that in 2008?
Ensure brevity in your answer.  2.66. What is the ratio of the Tax (as % of total tax revenue) of Bhutan in 2006 to that in 2007?
Keep it short and to the point. 28.6. What is the ratio of the Tax (as % of total tax revenue) in Cambodia in 2006 to that in 2007?
Offer a very short reply. 1.15. What is the ratio of the Tax (as % of total tax revenue) of Egypt, Arab Rep. in 2006 to that in 2007?
Make the answer very short. 0.08. What is the ratio of the Tax (as % of total tax revenue) of Suriname in 2006 to that in 2007?
Provide a succinct answer. 1.19. What is the ratio of the Tax (as % of total tax revenue) of Bhutan in 2006 to that in 2008?
Your answer should be compact. 4.09. What is the ratio of the Tax (as % of total tax revenue) of Cambodia in 2006 to that in 2008?
Provide a succinct answer. 1.83. What is the ratio of the Tax (as % of total tax revenue) in Egypt, Arab Rep. in 2006 to that in 2008?
Keep it short and to the point. 0. What is the ratio of the Tax (as % of total tax revenue) of Suriname in 2006 to that in 2008?
Offer a very short reply. 1.95. What is the ratio of the Tax (as % of total tax revenue) in Bhutan in 2007 to that in 2008?
Your answer should be very brief. 0.14. What is the ratio of the Tax (as % of total tax revenue) of Cambodia in 2007 to that in 2008?
Provide a succinct answer. 1.59. What is the ratio of the Tax (as % of total tax revenue) in Egypt, Arab Rep. in 2007 to that in 2008?
Make the answer very short. 0.05. What is the ratio of the Tax (as % of total tax revenue) in Suriname in 2007 to that in 2008?
Your response must be concise. 1.64. What is the difference between the highest and the second highest Tax (as % of total tax revenue) in Bhutan?
Ensure brevity in your answer.  0. What is the difference between the highest and the second highest Tax (as % of total tax revenue) in Cambodia?
Make the answer very short. 3.56. What is the difference between the highest and the second highest Tax (as % of total tax revenue) in Egypt, Arab Rep.?
Offer a terse response. 0.36. What is the difference between the highest and the second highest Tax (as % of total tax revenue) of Suriname?
Ensure brevity in your answer.  0.11. What is the difference between the highest and the lowest Tax (as % of total tax revenue) of Bhutan?
Your response must be concise. 0.03. What is the difference between the highest and the lowest Tax (as % of total tax revenue) in Cambodia?
Keep it short and to the point. 9.28. What is the difference between the highest and the lowest Tax (as % of total tax revenue) of Egypt, Arab Rep.?
Provide a succinct answer. 0.38. What is the difference between the highest and the lowest Tax (as % of total tax revenue) of Suriname?
Provide a succinct answer. 0.53. 